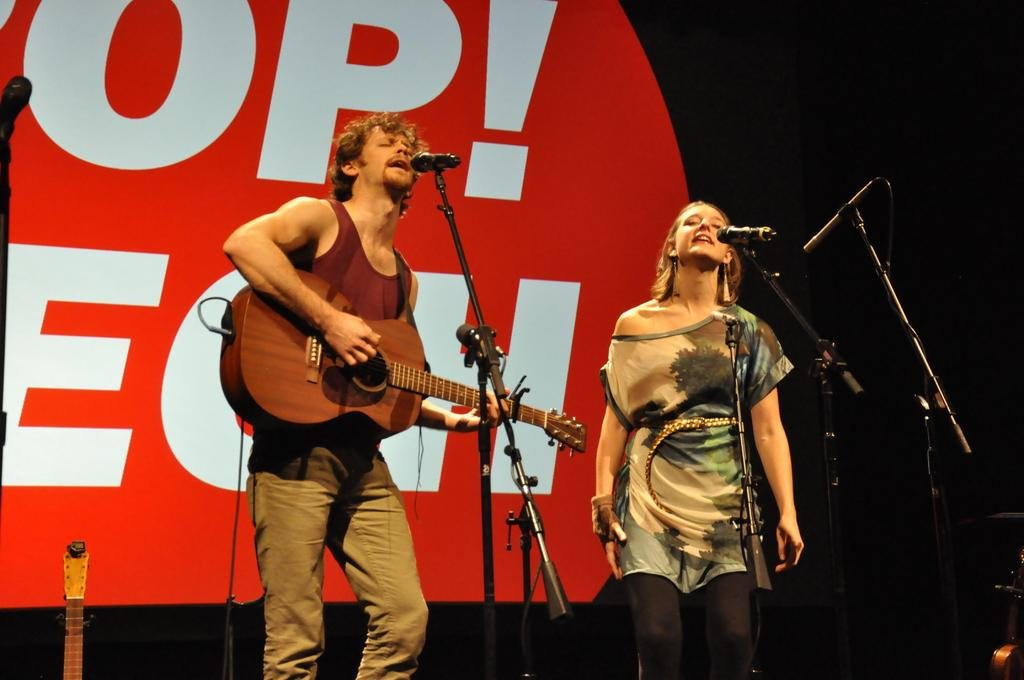Who are the people in the image? There is a man and a woman in the image. What are the man and woman doing in the image? Both the man and woman are singing on a mic. What instrument is the man playing in the image? The man is playing a guitar. What can be seen in the background of the image? There is a banner in the background of the image. What type of brick is the man using to play the guitar in the image? There is no brick present in the image, and the man is playing a guitar, not a brick. 